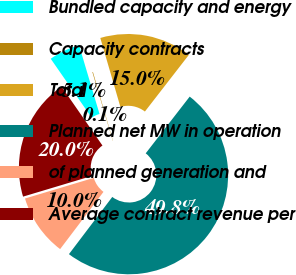Convert chart. <chart><loc_0><loc_0><loc_500><loc_500><pie_chart><fcel>Bundled capacity and energy<fcel>Capacity contracts<fcel>Total<fcel>Planned net MW in operation<fcel>of planned generation and<fcel>Average contract revenue per<nl><fcel>5.06%<fcel>0.09%<fcel>15.01%<fcel>49.82%<fcel>10.04%<fcel>19.98%<nl></chart> 